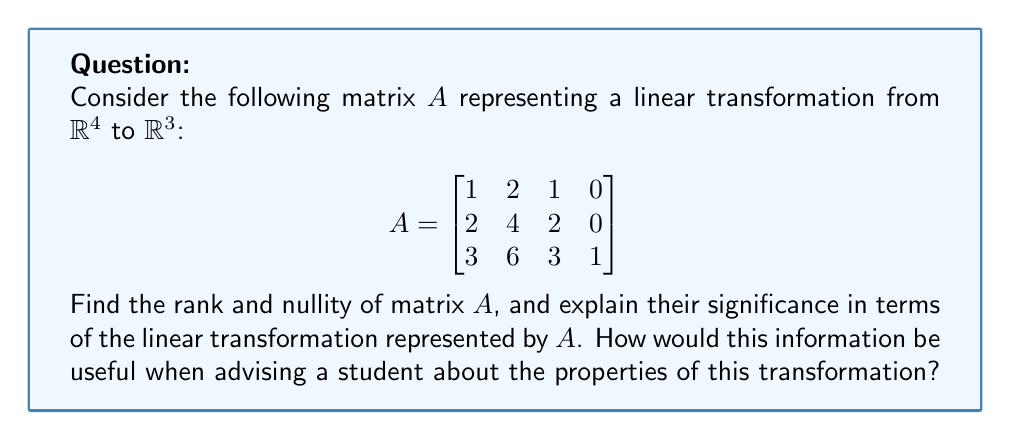Could you help me with this problem? To find the rank and nullity of matrix $A$, we'll follow these steps:

1) First, let's find the rank of $A$ by reducing it to row echelon form:

   $$\begin{bmatrix}
   1 & 2 & 1 & 0 \\
   2 & 4 & 2 & 0 \\
   3 & 6 & 3 & 1
   \end{bmatrix} \sim
   \begin{bmatrix}
   1 & 2 & 1 & 0 \\
   0 & 0 & 0 & 0 \\
   0 & 0 & 0 & 1
   \end{bmatrix}$$

2) The number of non-zero rows in the row echelon form is 2, so the rank of $A$ is 2.

3) The nullity is calculated using the rank-nullity theorem:
   $\text{nullity}(A) = \text{dim}(\text{domain}) - \text{rank}(A)$
   
   Here, $\text{dim}(\text{domain}) = 4$ (number of columns in $A$)
   
   So, $\text{nullity}(A) = 4 - 2 = 2$

4) Interpretation:
   - Rank = 2: This means the dimension of the image (output) of the transformation is 2. The transformation maps $\mathbb{R}^4$ onto a 2-dimensional subspace of $\mathbb{R}^3$.
   - Nullity = 2: This means the dimension of the null space (kernel) of the transformation is 2. There's a 2-dimensional subspace of $\mathbb{R}^4$ that gets mapped to the zero vector.

5) Significance for advising:
   - The transformation is not one-to-one (injective) because the nullity is non-zero.
   - The transformation is not onto (surjective) because the rank is less than the dimension of the codomain (3).
   - There will be infinite solutions to the equation $Ax = b$ for some vectors $b$, and no solutions for others.
   - Any vector in $\mathbb{R}^3$ can be uniquely decomposed into a sum of a vector in the image of $A$ and a vector orthogonal to the image of $A$.
Answer: Rank = 2, Nullity = 2. The transformation maps $\mathbb{R}^4$ onto a 2D subspace of $\mathbb{R}^3$, with a 2D null space. 